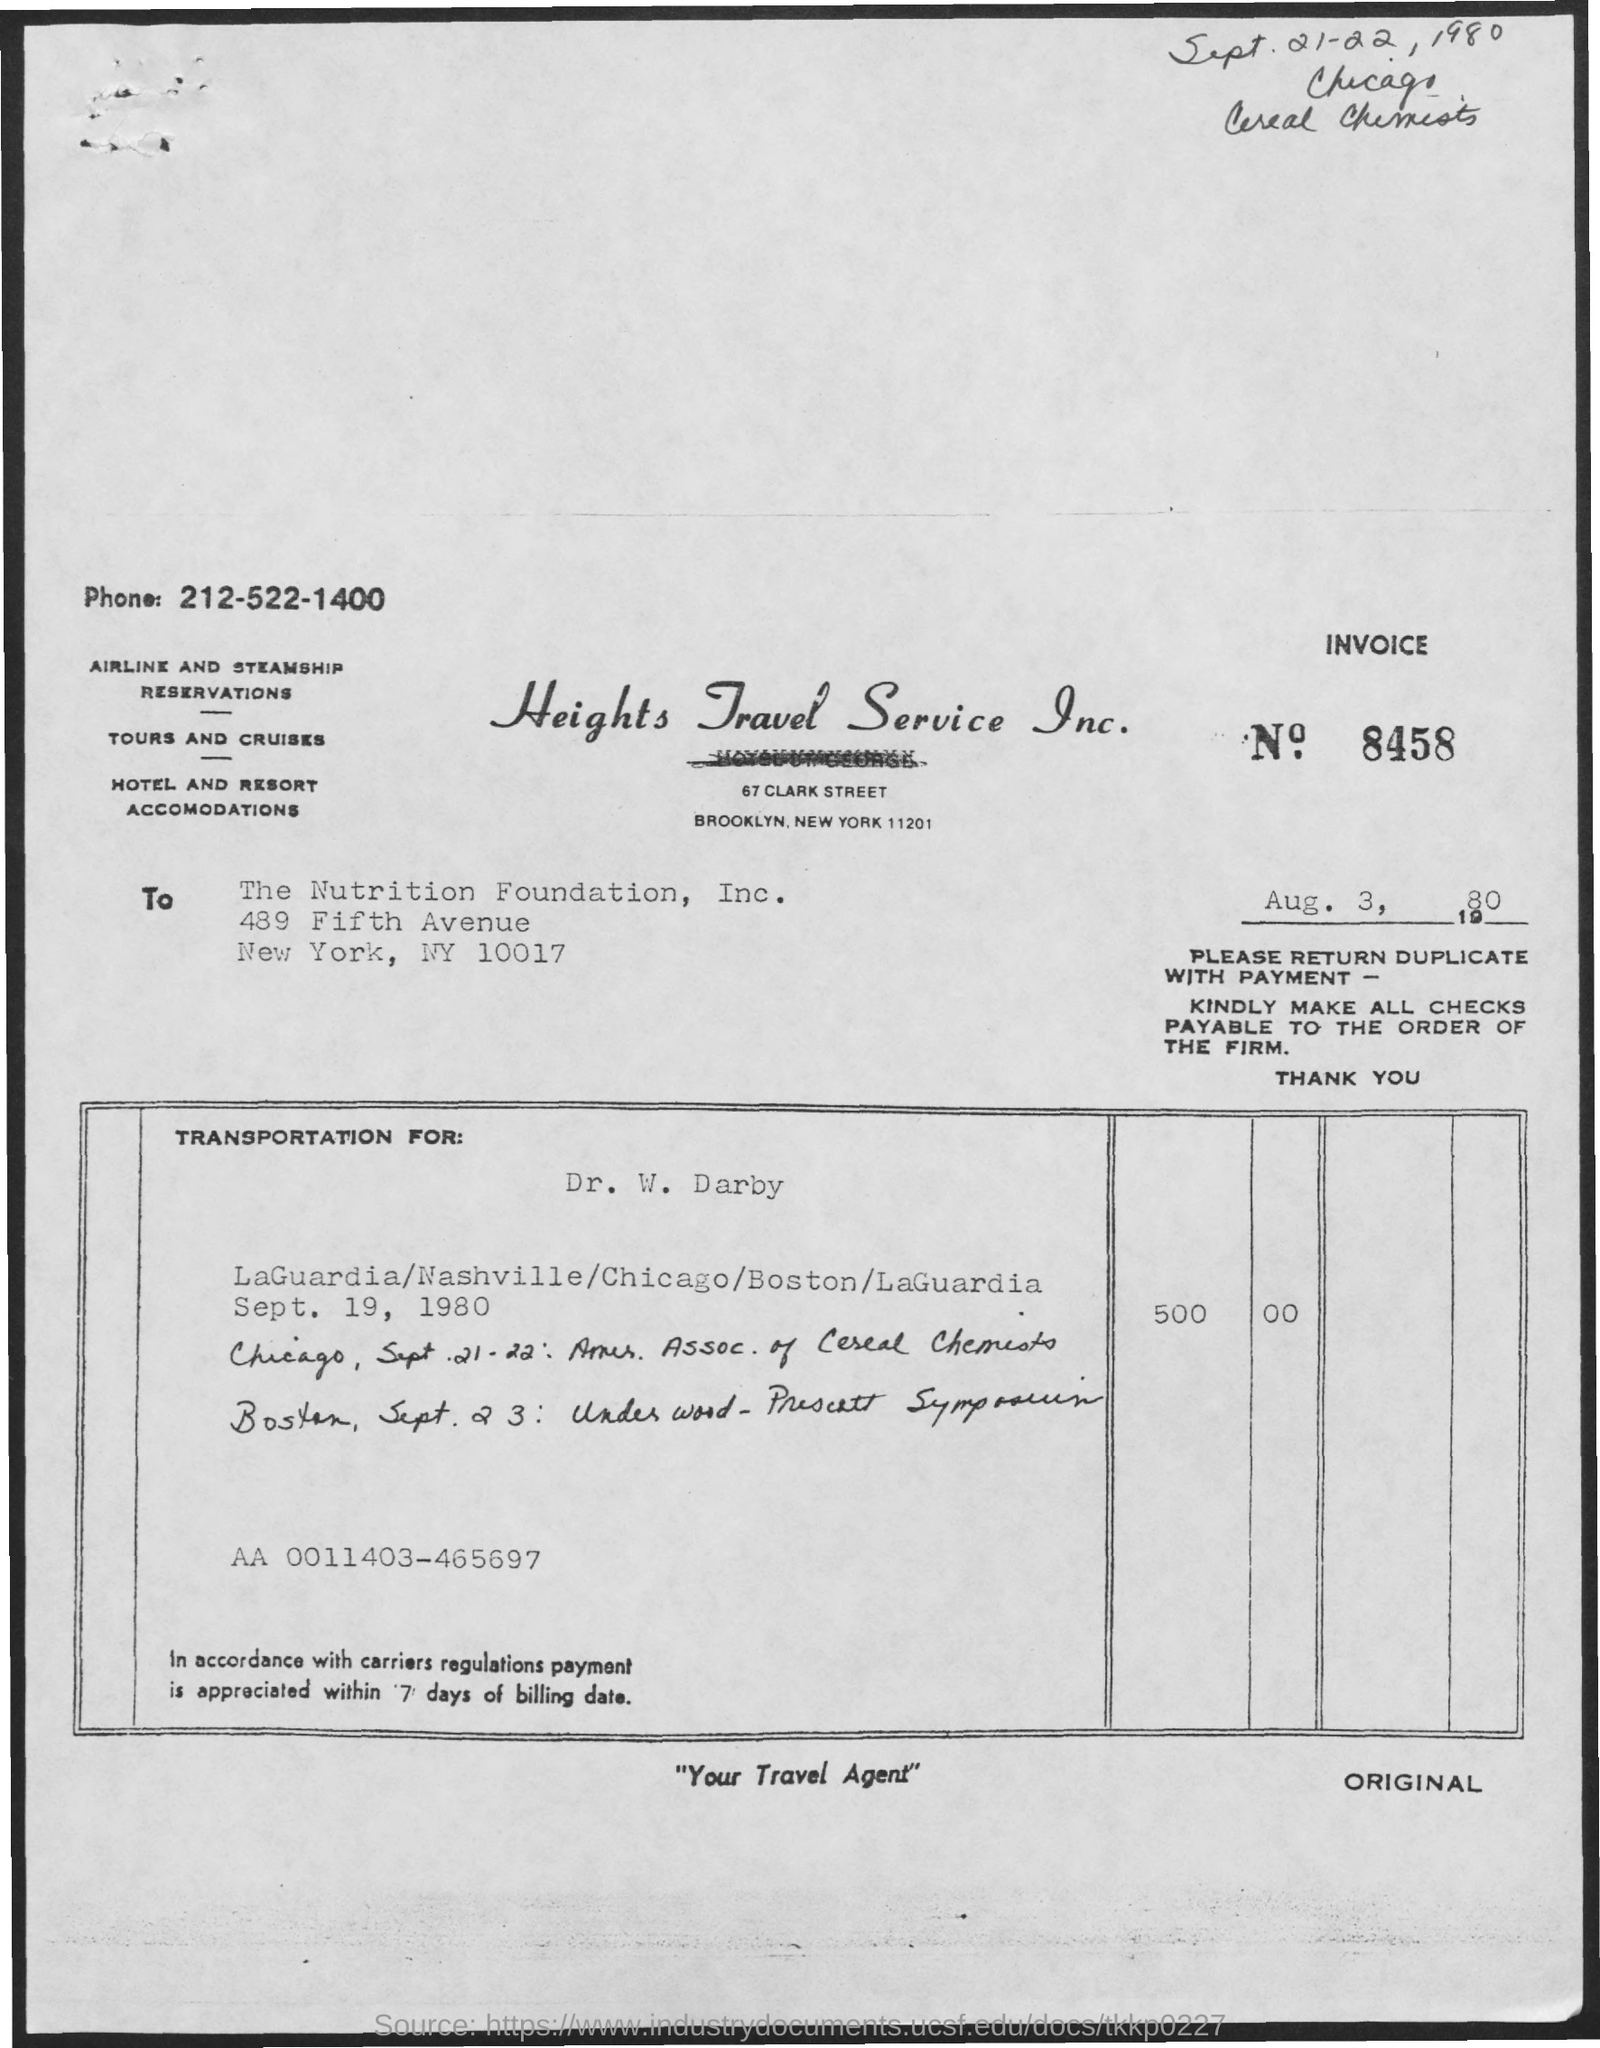What is the Invoice No.?
Your response must be concise. 8458. What is the title of the document?
Your response must be concise. Heights Travel Service Inc. What is the phone number mentioned in the document?
Provide a succinct answer. 212-522-1400. What is the date mentioned below the invoice number?
Offer a terse response. Aug. 3, 1980. 